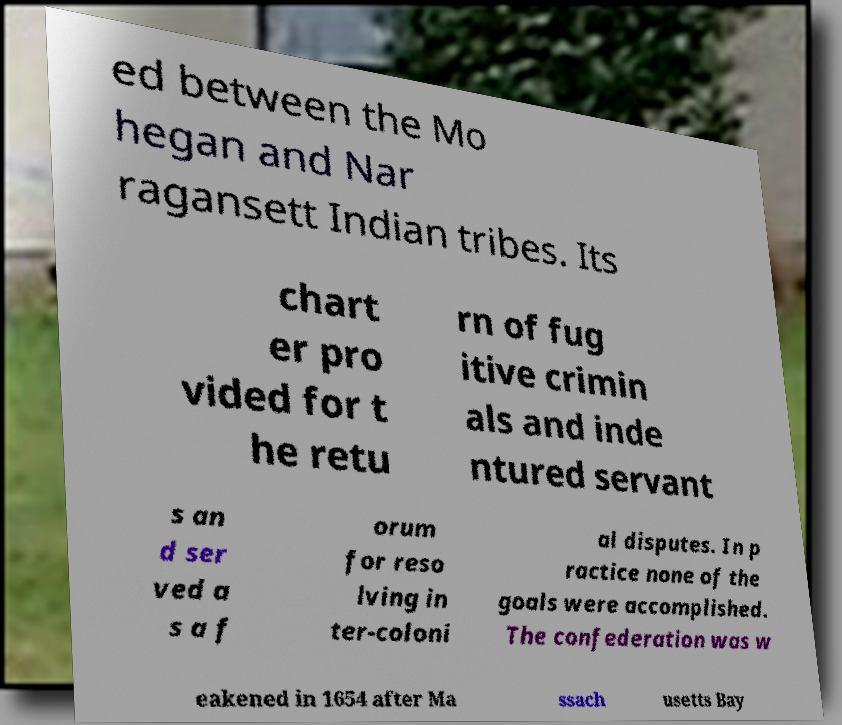Please read and relay the text visible in this image. What does it say? ed between the Mo hegan and Nar ragansett Indian tribes. Its chart er pro vided for t he retu rn of fug itive crimin als and inde ntured servant s an d ser ved a s a f orum for reso lving in ter-coloni al disputes. In p ractice none of the goals were accomplished. The confederation was w eakened in 1654 after Ma ssach usetts Bay 